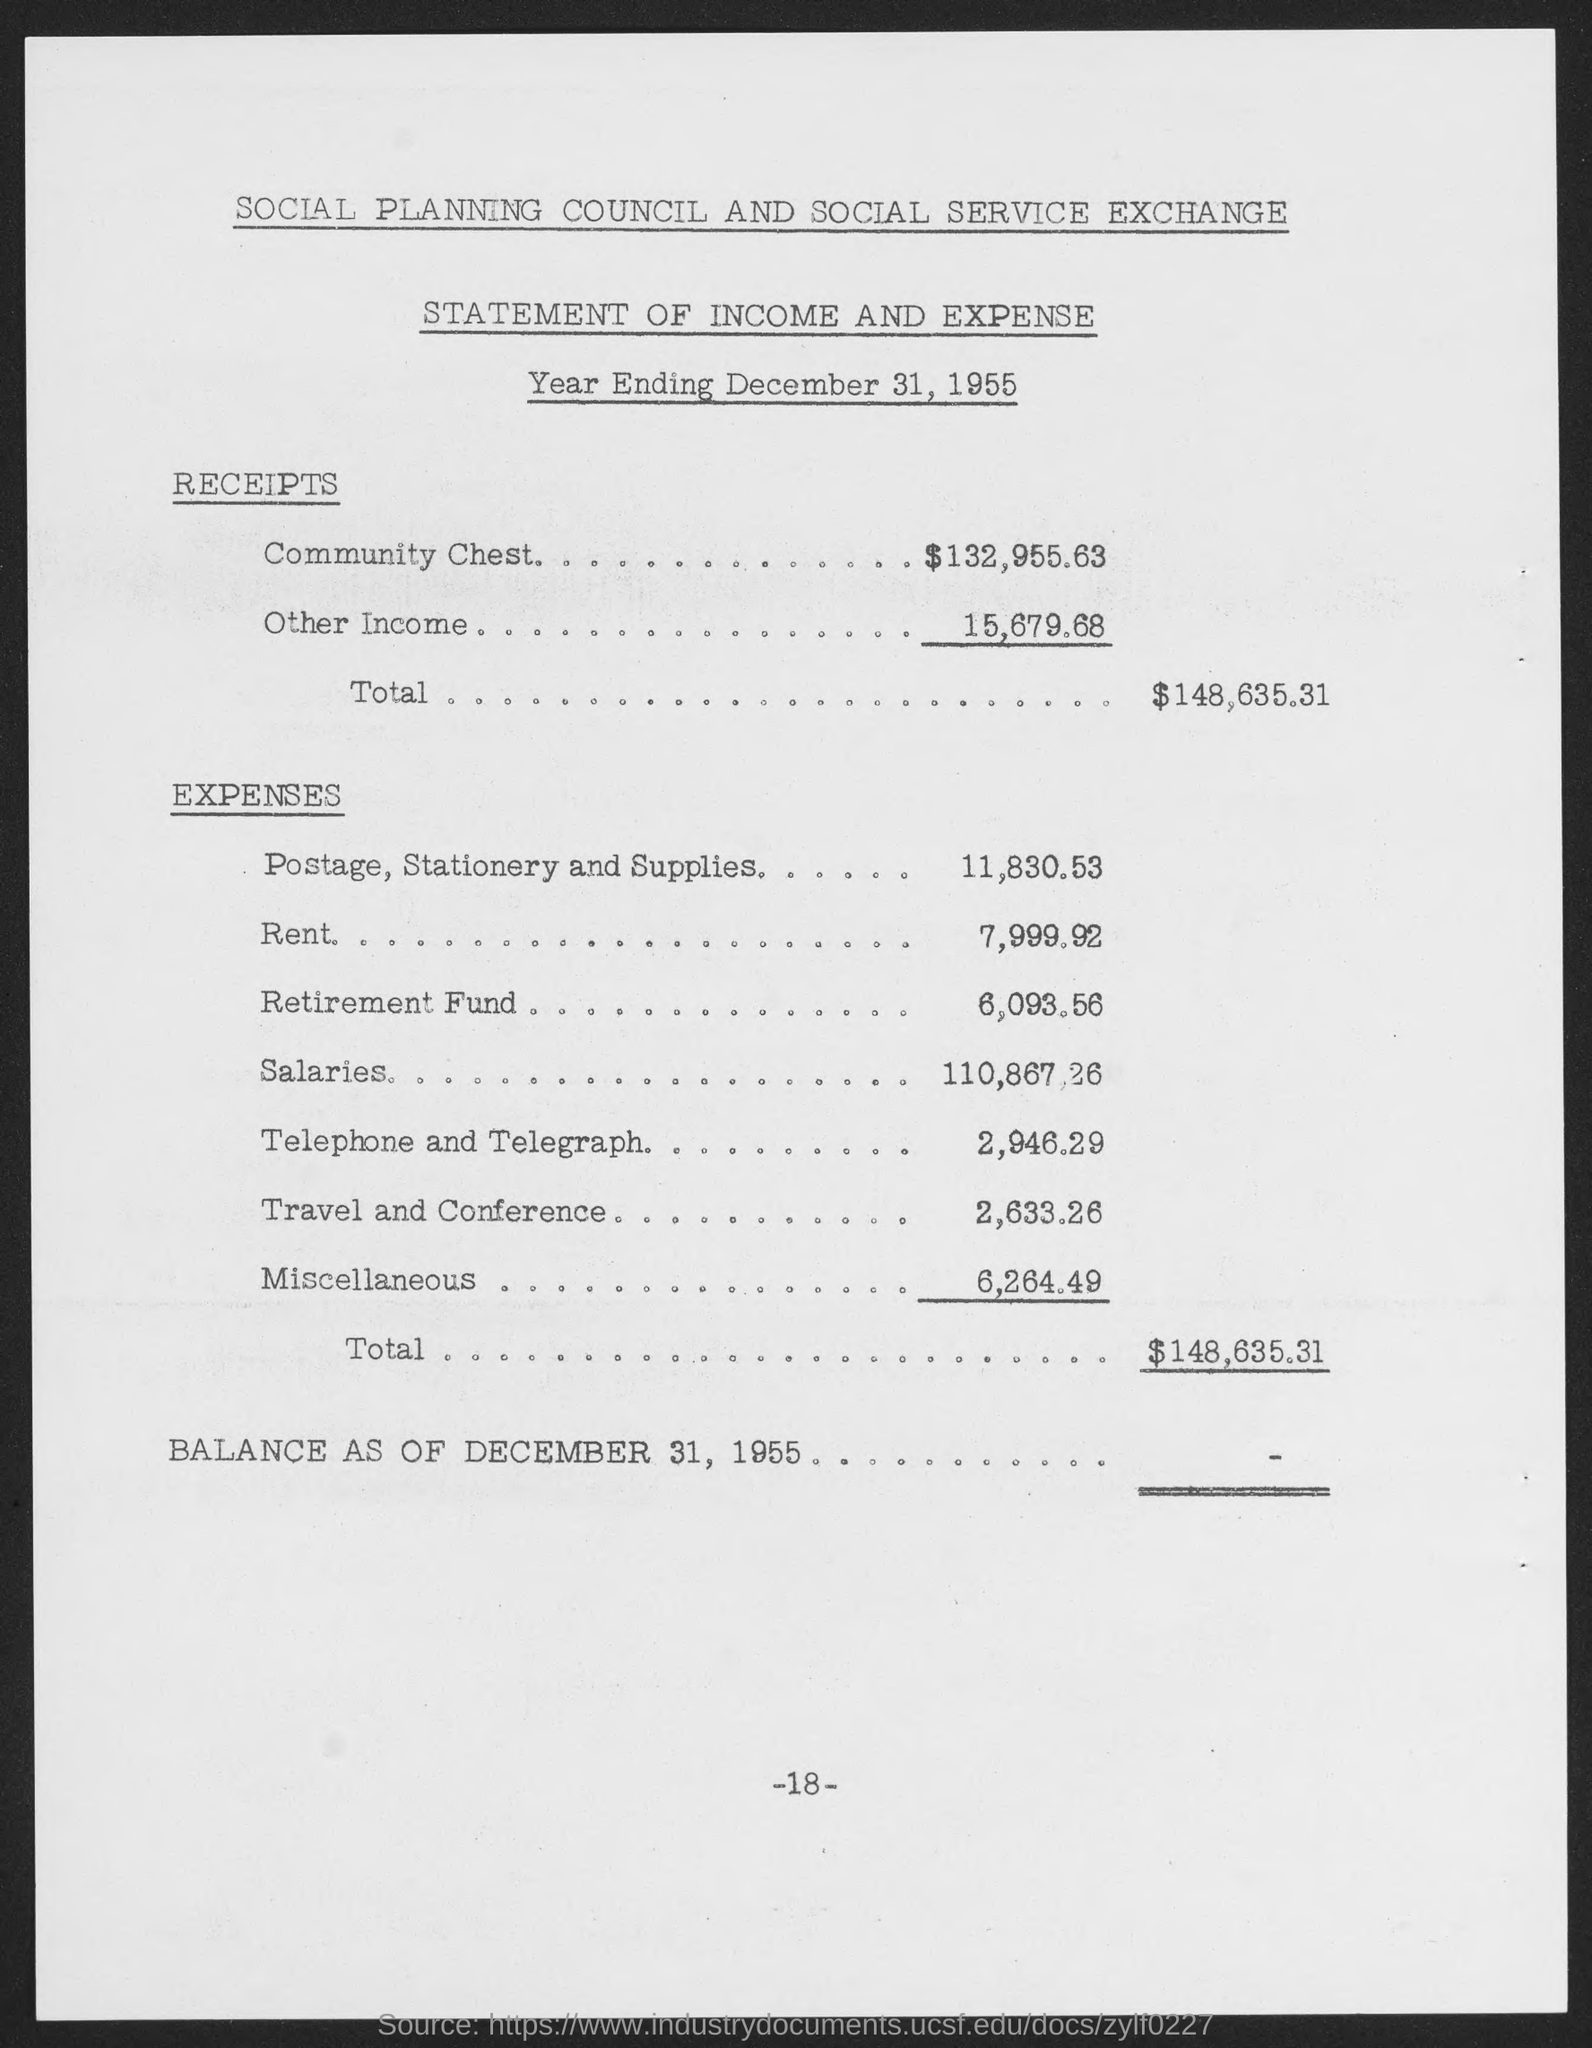Mention a couple of crucial points in this snapshot. The total amount of expenses is $148,635.31. The expense for telephone and telegraph was 2,946.29. There was an expense of $2,633.26 for travel and conference. The expense for the retirement fund is 6,093.56. The expense for rent is $7,999.92. 